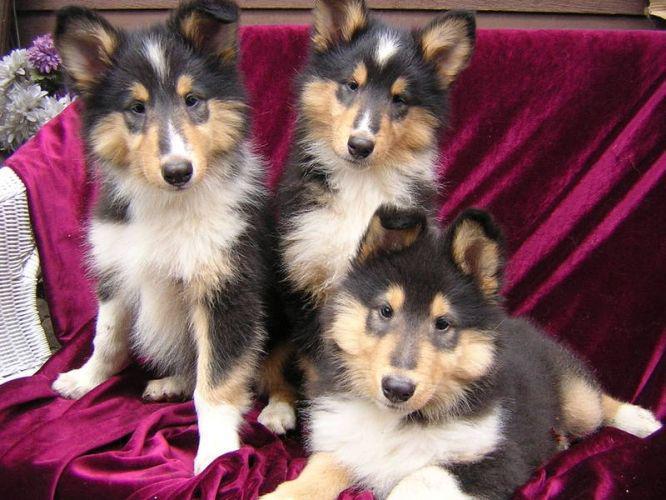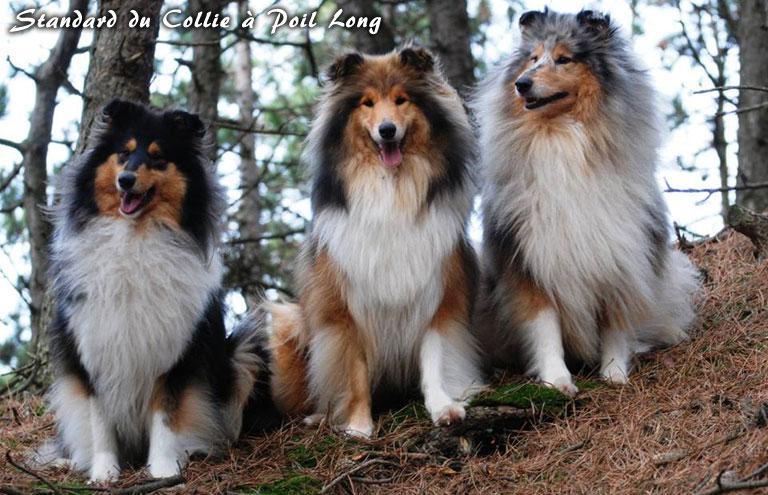The first image is the image on the left, the second image is the image on the right. For the images displayed, is the sentence "The right image contains exactly one dog." factually correct? Answer yes or no. No. The first image is the image on the left, the second image is the image on the right. For the images displayed, is the sentence "There is a total of three dogs." factually correct? Answer yes or no. No. 